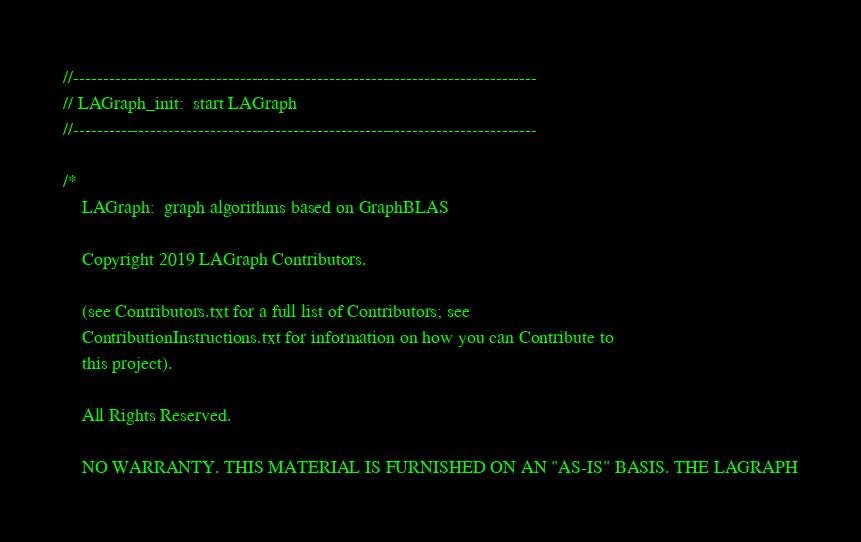<code> <loc_0><loc_0><loc_500><loc_500><_C_>//------------------------------------------------------------------------------
// LAGraph_init:  start LAGraph
//------------------------------------------------------------------------------

/*
    LAGraph:  graph algorithms based on GraphBLAS

    Copyright 2019 LAGraph Contributors.

    (see Contributors.txt for a full list of Contributors; see
    ContributionInstructions.txt for information on how you can Contribute to
    this project).

    All Rights Reserved.

    NO WARRANTY. THIS MATERIAL IS FURNISHED ON AN "AS-IS" BASIS. THE LAGRAPH</code> 